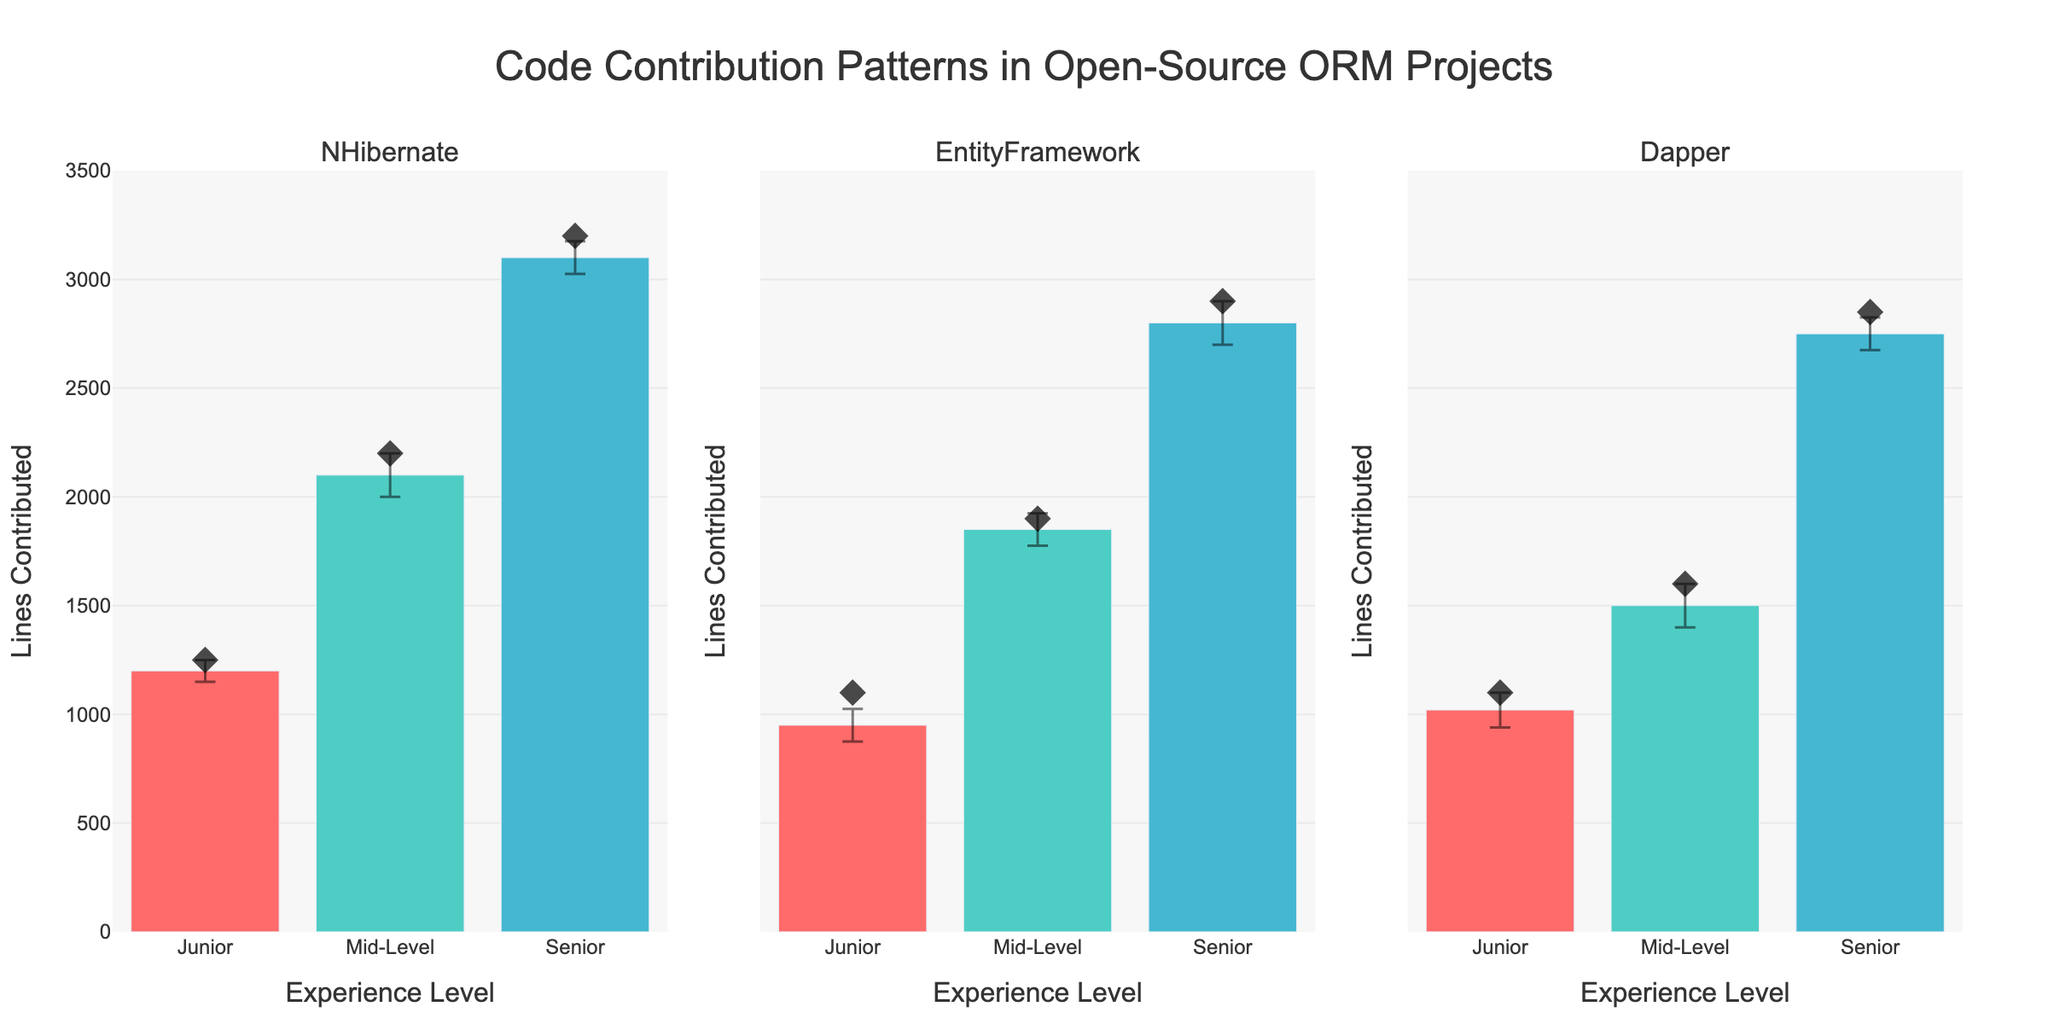What's the title of the figure? The title of the figure is located at the top and is typically in a larger font.
Answer: Code Contribution Patterns in Open-Source ORM Projects What are the three projects shown in the subplots? The subplot titles indicate the projects. They are placed above each subplot.
Answer: NHibernate, EntityFramework, Dapper Which experience level has the highest mean contributions for NHibernate? By examining the scatter plot markers within the NHibernate subplot, the highest point is for the Senior level.
Answer: Senior How many experience levels are shown for each project? Each subplot has three groups represented on the x-axis, corresponding to the three experience levels.
Answer: 3 What is the difference in mean contributions between Junior and Senior experience levels for Dapper? Mean contributions for Senior is 2850 and for Junior is 1100. The difference is 2850 - 1100 = 1750.
Answer: 1750 Which project has the largest contribution error for the Mid-Level experience tier? Mid-Level error bars are largest for Dapper, visible as the longest error bar in that subplot.
Answer: Dapper Which experience level has the smallest error margin for contributions in EntityFramework? By comparing error bars vertically within the EntityFramework subplot, the Junior level has the smallest error margin.
Answer: Junior Compare the lines contributed by Mid-Level developers in NHibernate and EntityFramework. Which is greater? For Mid-Level, NHibernate is 2100 lines, and EntityFramework is 1850 lines. 2100 > 1850.
Answer: NHibernate What is the range of lines contributed by Senior developers across the projects? The Senior values are 3100 (NHibernate), 2800 (EntityFramework), and 2750 (Dapper). The range is from 2750 to 3100.
Answer: 2750 to 3100 How does the variance in contributions compare between the Junior and Senior levels for NHibernate? For NHibernate, Junior has an error of 50, and Senior has an error of 75. Hence, the Senior level has a larger variance.
Answer: Senior level has larger variance 